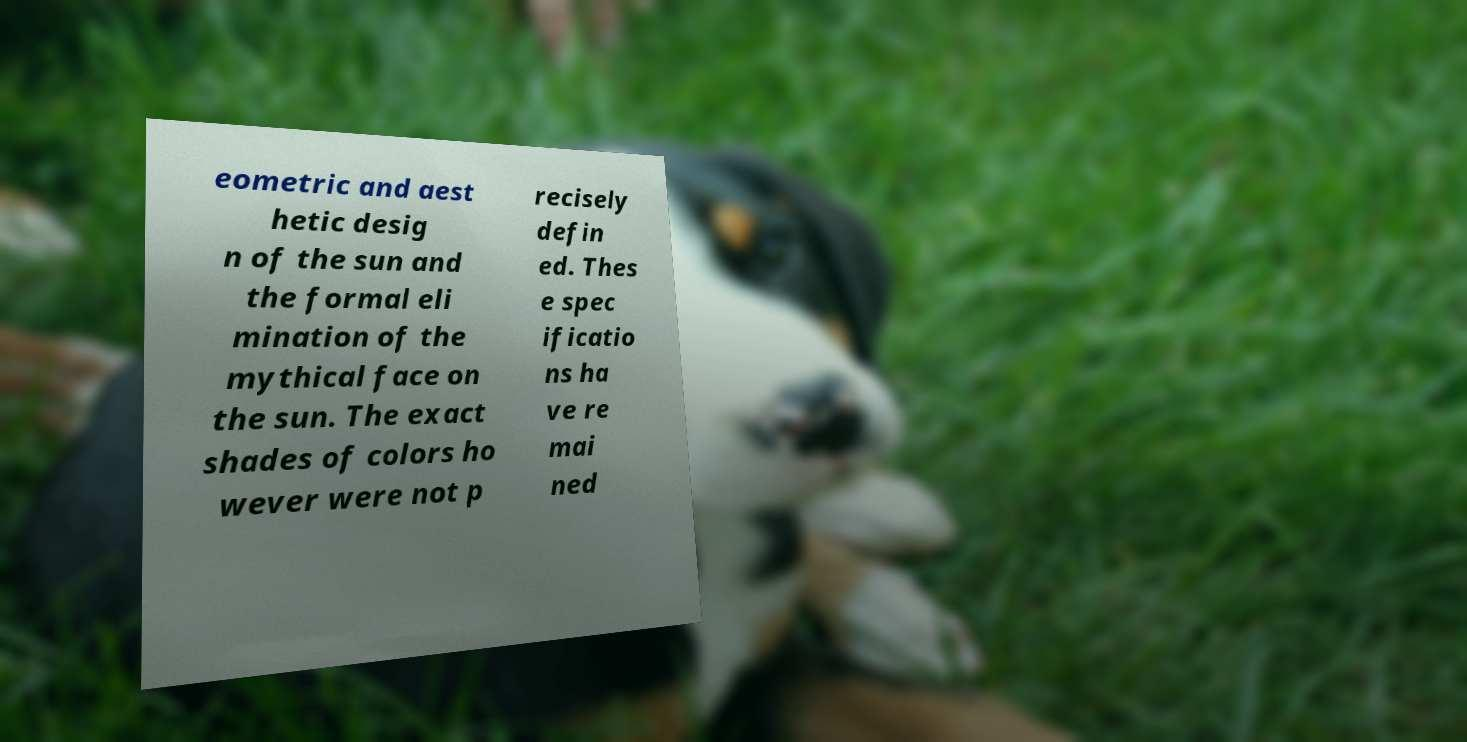Can you read and provide the text displayed in the image?This photo seems to have some interesting text. Can you extract and type it out for me? eometric and aest hetic desig n of the sun and the formal eli mination of the mythical face on the sun. The exact shades of colors ho wever were not p recisely defin ed. Thes e spec ificatio ns ha ve re mai ned 